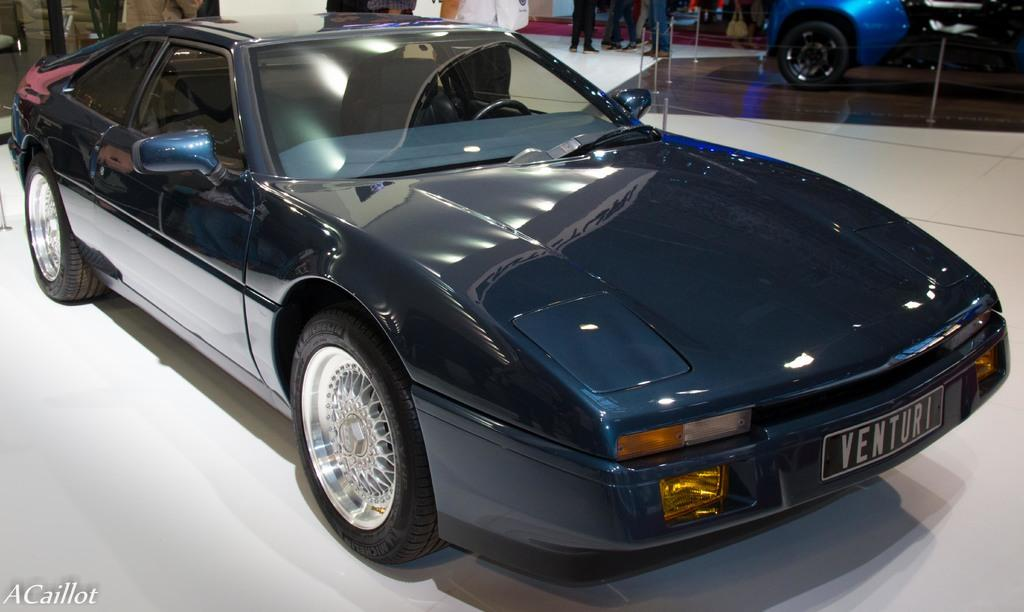How many cars are present in the image? There are two cars in the image. What else can be seen in the image besides the cars? There are poles, a rope, people, and text in the image. What might the rope be used for in the image? The rope could be used for various purposes, such as tying or hanging, but its specific use cannot be determined from the image. What is the content of the text in the image? The content of the text in the image cannot be determined without more information. Can you tell me how many ducks are swimming in the image? There are no ducks present in the image. What type of health advice is given in the image? There is no health advice present in the image. Is there a judge visible in the image? There is no judge present in the image. 